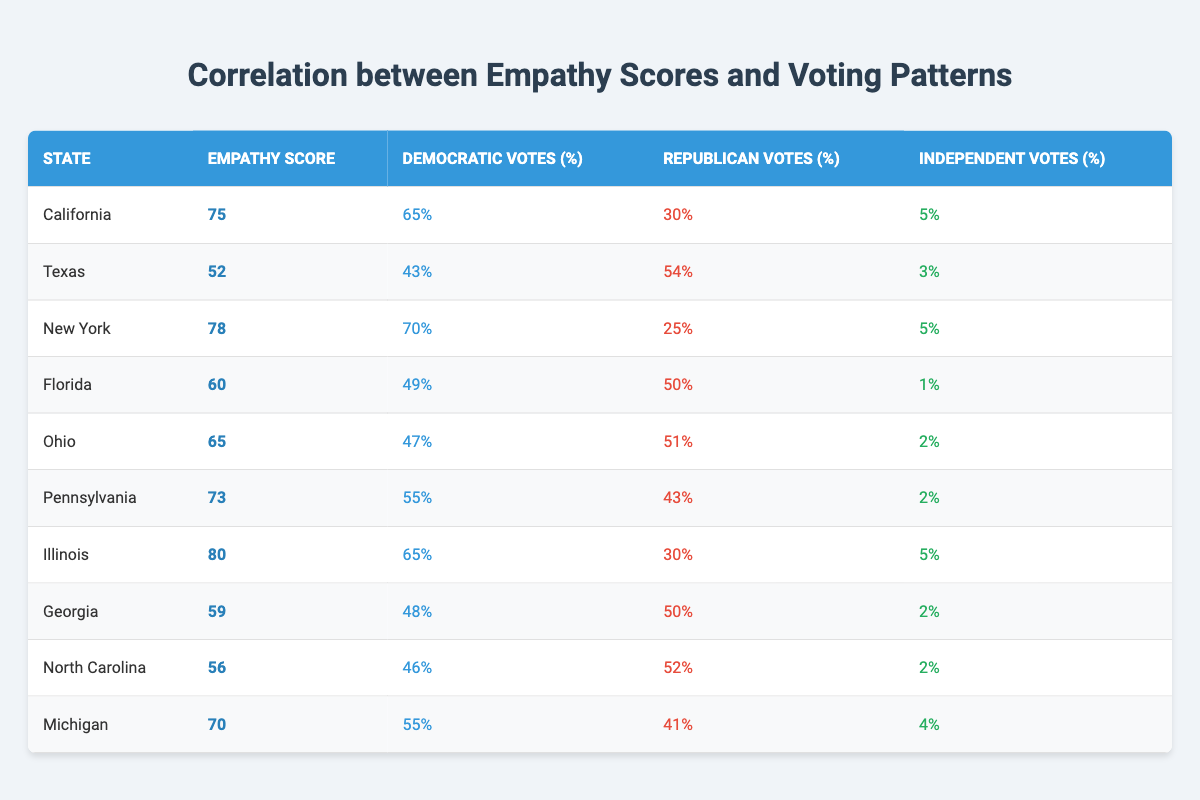What is the empathy score for New York? The table shows that the empathy score is specifically listed for each state, and for New York, it is 78.
Answer: 78 Which state has the highest percentage of Democratic votes? By examining the Democratic votes percentage column, California and New York both have the highest figures of 65% and 70%, respectively, with New York having the largest.
Answer: New York How many states have an empathy score above 70? The states with empathy scores above 70 are California (75), New York (78), Pennsylvania (73), and Illinois (80). This totals four states.
Answer: 4 What is the difference in empathy scores between Texas and New York? The empathy score for Texas is 52, and for New York, it is 78. The difference is computed as 78 - 52 = 26.
Answer: 26 Is the percentage of Republican votes in Georgia higher than in Pennsylvania? In Georgia, the Republican votes percentage is 50%, while in Pennsylvania it is 43%. Since 50% is greater than 43%, the statement is true.
Answer: Yes What is the total percentage of independent votes across all states? To find the total independent votes percentage, I will sum the percentages: 5 + 3 + 5 + 1 + 2 + 2 + 5 + 2 + 2 + 4 = 27.
Answer: 27 Which state has the lowest empathy score, and what is that score? By checking the empathy scores listed, Texas has the lowest score at 52.
Answer: Texas, 52 What is the average empathy score across all the states? The empathy scores to add are: 75, 52, 78, 60, 65, 73, 80, 59, 56, 70. The total is 75 + 52 + 78 + 60 + 65 + 73 + 80 + 59 + 56 + 70 =  717. There are 10 states, so the average is 717 / 10 = 71.7.
Answer: 71.7 Which state has the highest empathy score, and what is its Democratic votes percentage? The highest empathy score of 80 belongs to Illinois. The Democratic votes percentage for Illinois is 65%.
Answer: Illinois, 65% What is the relationship between empathy scores and Democratic votes for states with scores below 60? The states are Texas (52, 43%), Florida (60, 49%), Georgia (59, 48%), and North Carolina (56, 46%). Generally, lower empathy scores correspond with lower percentages of Democratic votes in these states.
Answer: Negative correlation 